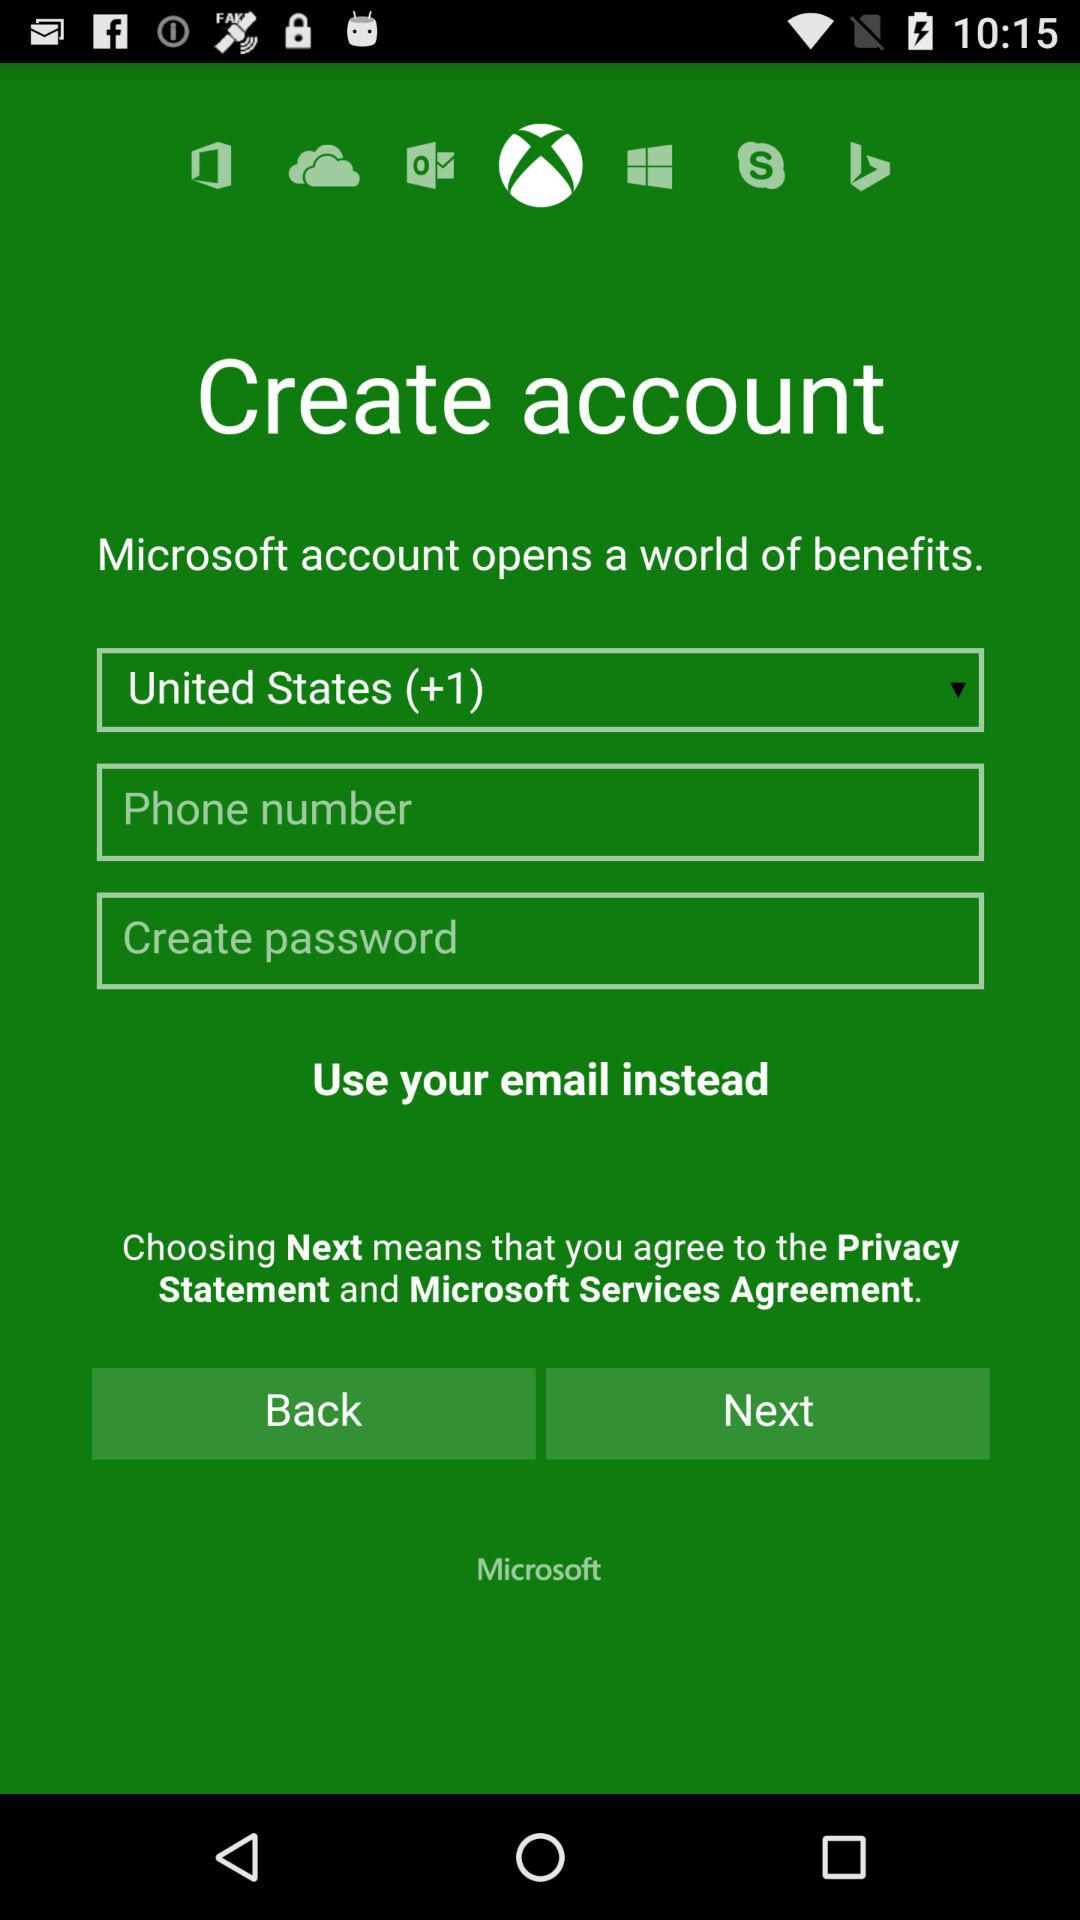Which country is selected? The selected country is the United States. 